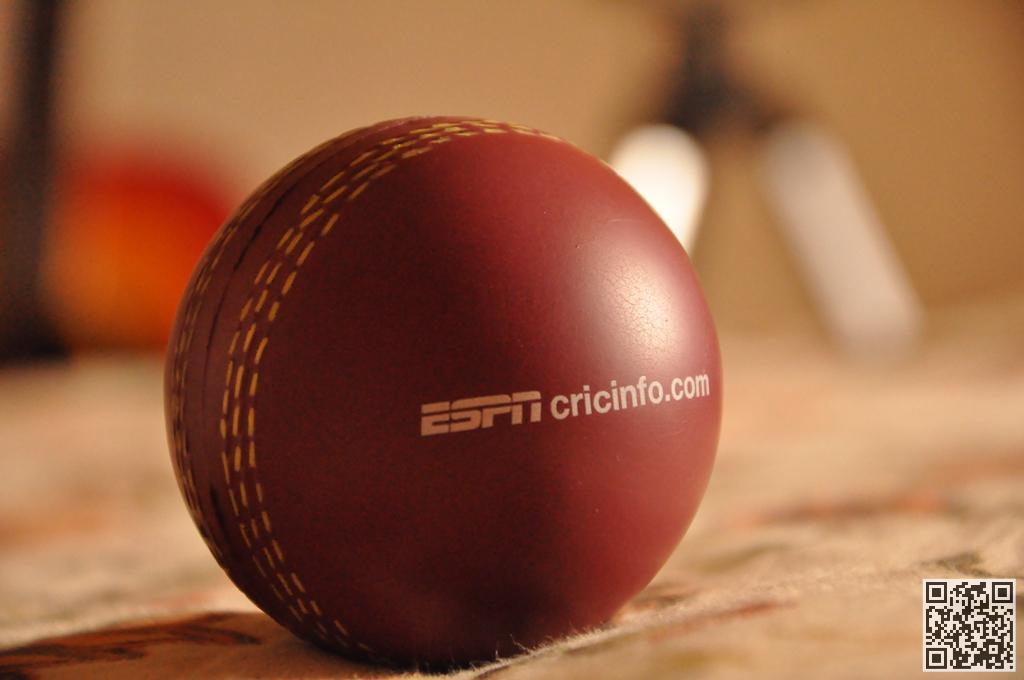What object is on the floor in the image? There is a cricket ball on the floor. Can you describe the background of the image? The background of the image is blurry. What type of sweater is the authority figure wearing in the image? There is no authority figure or sweater present in the image; it only features a cricket ball on the floor and a blurry background. 